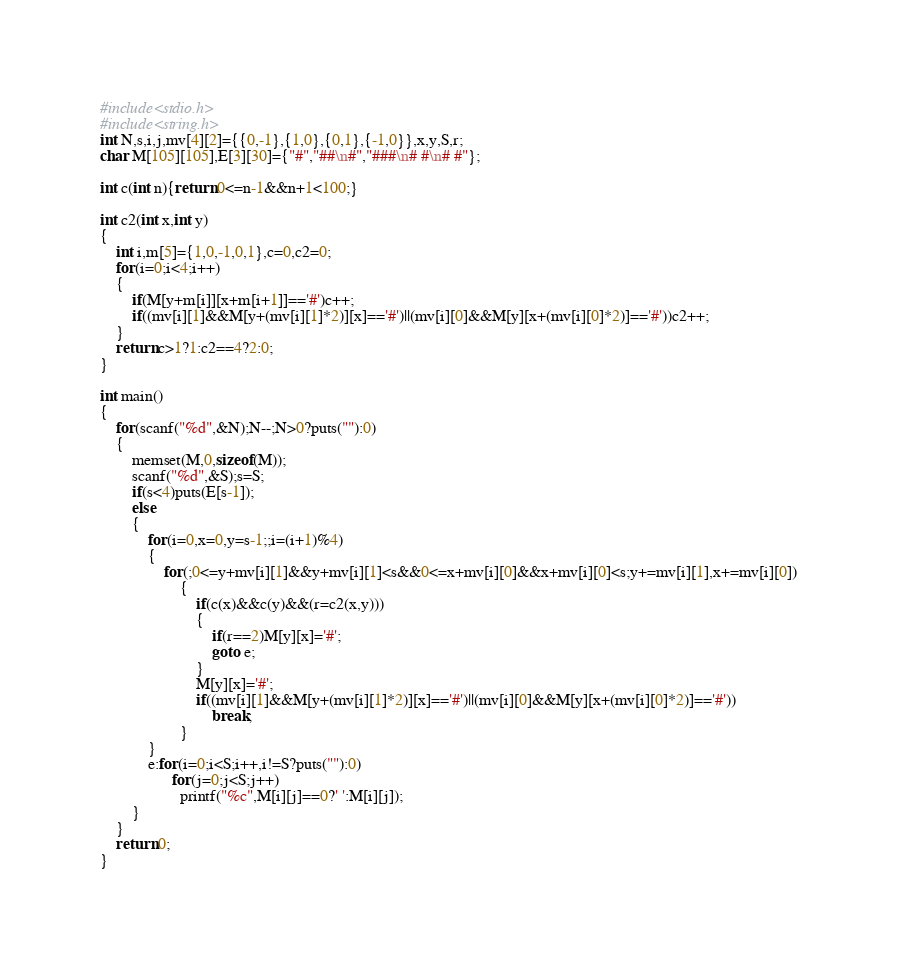Convert code to text. <code><loc_0><loc_0><loc_500><loc_500><_C_>#include<stdio.h>
#include<string.h>
int N,s,i,j,mv[4][2]={{0,-1},{1,0},{0,1},{-1,0}},x,y,S,r;
char M[105][105],E[3][30]={"#","##\n#","###\n# #\n# #"};

int c(int n){return 0<=n-1&&n+1<100;}

int c2(int x,int y)
{
	int i,m[5]={1,0,-1,0,1},c=0,c2=0;
	for(i=0;i<4;i++)
	{
		if(M[y+m[i]][x+m[i+1]]=='#')c++;
		if((mv[i][1]&&M[y+(mv[i][1]*2)][x]=='#')||(mv[i][0]&&M[y][x+(mv[i][0]*2)]=='#'))c2++;
	}
	return c>1?1:c2==4?2:0;
}

int main()
{
	for(scanf("%d",&N);N--;N>0?puts(""):0)
	{
		memset(M,0,sizeof(M));
		scanf("%d",&S);s=S;
		if(s<4)puts(E[s-1]);
		else
		{
			for(i=0,x=0,y=s-1;;i=(i+1)%4)
			{
				for(;0<=y+mv[i][1]&&y+mv[i][1]<s&&0<=x+mv[i][0]&&x+mv[i][0]<s;y+=mv[i][1],x+=mv[i][0])
					{
						if(c(x)&&c(y)&&(r=c2(x,y)))
						{
							if(r==2)M[y][x]='#';
							goto e;
						}
						M[y][x]='#';
						if((mv[i][1]&&M[y+(mv[i][1]*2)][x]=='#')||(mv[i][0]&&M[y][x+(mv[i][0]*2)]=='#'))
							break;
					}
			}
			e:for(i=0;i<S;i++,i!=S?puts(""):0)
				  for(j=0;j<S;j++)
					printf("%c",M[i][j]==0?' ':M[i][j]);
		}
	}
	return 0;
}</code> 